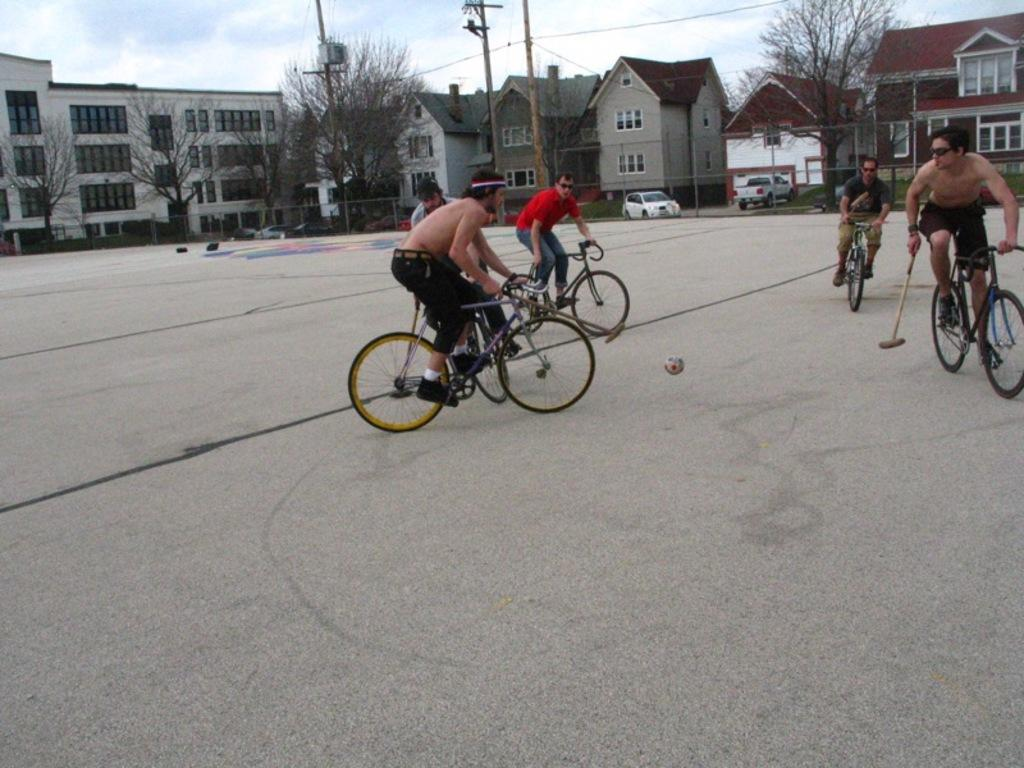How many persons are in the image? There is a group of persons in the image. What are the persons doing in the image? The persons are riding bicycles and kicking a ball with a bat. What can be seen in the background of the image? There are buildings, trees, a pole, a car, and a house in the background of the image. What type of toothbrush is being used by the persons in the image? There is no toothbrush present in the image; the persons are riding bicycles and kicking a ball with a bat. What holiday is being celebrated in the image? There is no indication of a holiday being celebrated in the image. 